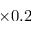<formula> <loc_0><loc_0><loc_500><loc_500>\times 0 . 2</formula> 